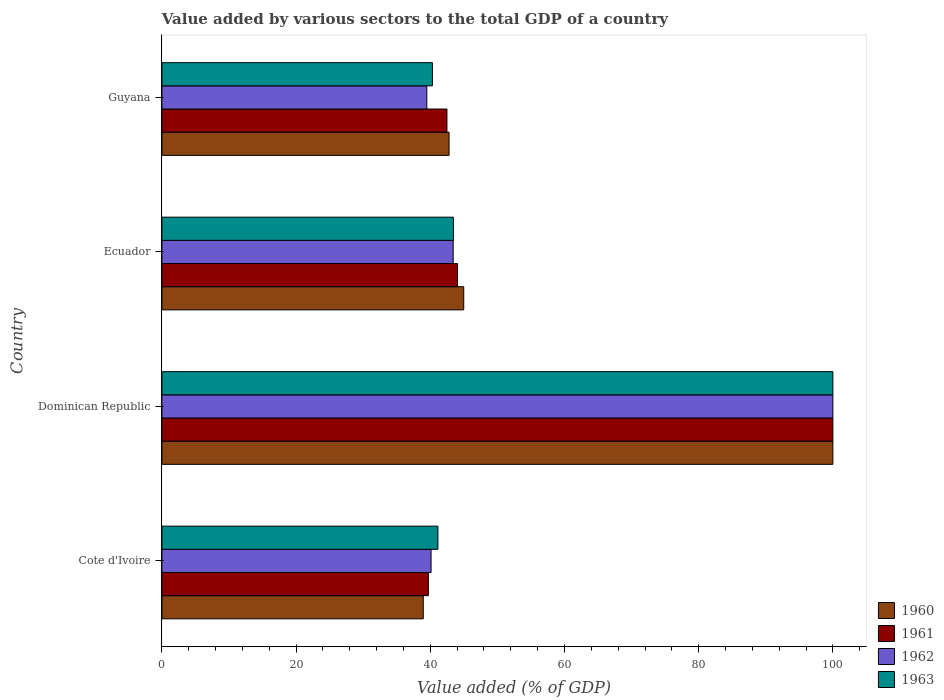How many different coloured bars are there?
Give a very brief answer. 4. Are the number of bars per tick equal to the number of legend labels?
Provide a short and direct response. Yes. Are the number of bars on each tick of the Y-axis equal?
Provide a succinct answer. Yes. What is the label of the 4th group of bars from the top?
Your answer should be very brief. Cote d'Ivoire. What is the value added by various sectors to the total GDP in 1961 in Cote d'Ivoire?
Your answer should be compact. 39.71. Across all countries, what is the maximum value added by various sectors to the total GDP in 1960?
Your response must be concise. 100. Across all countries, what is the minimum value added by various sectors to the total GDP in 1962?
Ensure brevity in your answer.  39.48. In which country was the value added by various sectors to the total GDP in 1963 maximum?
Ensure brevity in your answer.  Dominican Republic. In which country was the value added by various sectors to the total GDP in 1960 minimum?
Make the answer very short. Cote d'Ivoire. What is the total value added by various sectors to the total GDP in 1960 in the graph?
Make the answer very short. 226.74. What is the difference between the value added by various sectors to the total GDP in 1963 in Dominican Republic and that in Ecuador?
Offer a very short reply. 56.56. What is the difference between the value added by various sectors to the total GDP in 1963 in Guyana and the value added by various sectors to the total GDP in 1960 in Cote d'Ivoire?
Make the answer very short. 1.36. What is the average value added by various sectors to the total GDP in 1963 per country?
Keep it short and to the point. 56.22. What is the ratio of the value added by various sectors to the total GDP in 1963 in Cote d'Ivoire to that in Ecuador?
Ensure brevity in your answer.  0.95. Is the difference between the value added by various sectors to the total GDP in 1960 in Cote d'Ivoire and Dominican Republic greater than the difference between the value added by various sectors to the total GDP in 1963 in Cote d'Ivoire and Dominican Republic?
Provide a succinct answer. No. What is the difference between the highest and the second highest value added by various sectors to the total GDP in 1962?
Ensure brevity in your answer.  56.59. What is the difference between the highest and the lowest value added by various sectors to the total GDP in 1962?
Give a very brief answer. 60.52. Is the sum of the value added by various sectors to the total GDP in 1962 in Cote d'Ivoire and Ecuador greater than the maximum value added by various sectors to the total GDP in 1961 across all countries?
Keep it short and to the point. No. What does the 3rd bar from the top in Guyana represents?
Keep it short and to the point. 1961. Are all the bars in the graph horizontal?
Offer a terse response. Yes. How many countries are there in the graph?
Make the answer very short. 4. Does the graph contain any zero values?
Give a very brief answer. No. How many legend labels are there?
Your answer should be very brief. 4. How are the legend labels stacked?
Provide a short and direct response. Vertical. What is the title of the graph?
Your answer should be very brief. Value added by various sectors to the total GDP of a country. What is the label or title of the X-axis?
Keep it short and to the point. Value added (% of GDP). What is the Value added (% of GDP) of 1960 in Cote d'Ivoire?
Offer a terse response. 38.95. What is the Value added (% of GDP) in 1961 in Cote d'Ivoire?
Your response must be concise. 39.71. What is the Value added (% of GDP) of 1962 in Cote d'Ivoire?
Your answer should be compact. 40.11. What is the Value added (% of GDP) of 1963 in Cote d'Ivoire?
Make the answer very short. 41.13. What is the Value added (% of GDP) of 1960 in Dominican Republic?
Offer a very short reply. 100. What is the Value added (% of GDP) in 1961 in Dominican Republic?
Make the answer very short. 100. What is the Value added (% of GDP) in 1963 in Dominican Republic?
Provide a short and direct response. 100. What is the Value added (% of GDP) of 1960 in Ecuador?
Keep it short and to the point. 44.99. What is the Value added (% of GDP) of 1961 in Ecuador?
Make the answer very short. 44.05. What is the Value added (% of GDP) in 1962 in Ecuador?
Your answer should be compact. 43.41. What is the Value added (% of GDP) in 1963 in Ecuador?
Offer a very short reply. 43.44. What is the Value added (% of GDP) of 1960 in Guyana?
Ensure brevity in your answer.  42.8. What is the Value added (% of GDP) of 1961 in Guyana?
Make the answer very short. 42.48. What is the Value added (% of GDP) of 1962 in Guyana?
Offer a very short reply. 39.48. What is the Value added (% of GDP) of 1963 in Guyana?
Offer a very short reply. 40.31. Across all countries, what is the maximum Value added (% of GDP) of 1962?
Offer a terse response. 100. Across all countries, what is the minimum Value added (% of GDP) in 1960?
Your answer should be very brief. 38.95. Across all countries, what is the minimum Value added (% of GDP) of 1961?
Provide a short and direct response. 39.71. Across all countries, what is the minimum Value added (% of GDP) in 1962?
Your answer should be compact. 39.48. Across all countries, what is the minimum Value added (% of GDP) in 1963?
Make the answer very short. 40.31. What is the total Value added (% of GDP) of 1960 in the graph?
Keep it short and to the point. 226.74. What is the total Value added (% of GDP) of 1961 in the graph?
Keep it short and to the point. 226.25. What is the total Value added (% of GDP) of 1962 in the graph?
Provide a short and direct response. 223.01. What is the total Value added (% of GDP) of 1963 in the graph?
Offer a terse response. 224.89. What is the difference between the Value added (% of GDP) in 1960 in Cote d'Ivoire and that in Dominican Republic?
Make the answer very short. -61.05. What is the difference between the Value added (% of GDP) in 1961 in Cote d'Ivoire and that in Dominican Republic?
Give a very brief answer. -60.29. What is the difference between the Value added (% of GDP) in 1962 in Cote d'Ivoire and that in Dominican Republic?
Give a very brief answer. -59.89. What is the difference between the Value added (% of GDP) of 1963 in Cote d'Ivoire and that in Dominican Republic?
Offer a very short reply. -58.87. What is the difference between the Value added (% of GDP) in 1960 in Cote d'Ivoire and that in Ecuador?
Provide a succinct answer. -6.03. What is the difference between the Value added (% of GDP) of 1961 in Cote d'Ivoire and that in Ecuador?
Give a very brief answer. -4.34. What is the difference between the Value added (% of GDP) in 1962 in Cote d'Ivoire and that in Ecuador?
Give a very brief answer. -3.3. What is the difference between the Value added (% of GDP) of 1963 in Cote d'Ivoire and that in Ecuador?
Make the answer very short. -2.31. What is the difference between the Value added (% of GDP) of 1960 in Cote d'Ivoire and that in Guyana?
Offer a terse response. -3.84. What is the difference between the Value added (% of GDP) in 1961 in Cote d'Ivoire and that in Guyana?
Make the answer very short. -2.77. What is the difference between the Value added (% of GDP) in 1962 in Cote d'Ivoire and that in Guyana?
Your response must be concise. 0.63. What is the difference between the Value added (% of GDP) in 1963 in Cote d'Ivoire and that in Guyana?
Make the answer very short. 0.82. What is the difference between the Value added (% of GDP) in 1960 in Dominican Republic and that in Ecuador?
Give a very brief answer. 55.02. What is the difference between the Value added (% of GDP) in 1961 in Dominican Republic and that in Ecuador?
Provide a short and direct response. 55.95. What is the difference between the Value added (% of GDP) in 1962 in Dominican Republic and that in Ecuador?
Your answer should be very brief. 56.59. What is the difference between the Value added (% of GDP) of 1963 in Dominican Republic and that in Ecuador?
Offer a terse response. 56.56. What is the difference between the Value added (% of GDP) of 1960 in Dominican Republic and that in Guyana?
Your response must be concise. 57.2. What is the difference between the Value added (% of GDP) of 1961 in Dominican Republic and that in Guyana?
Offer a terse response. 57.52. What is the difference between the Value added (% of GDP) in 1962 in Dominican Republic and that in Guyana?
Offer a very short reply. 60.52. What is the difference between the Value added (% of GDP) of 1963 in Dominican Republic and that in Guyana?
Your response must be concise. 59.69. What is the difference between the Value added (% of GDP) in 1960 in Ecuador and that in Guyana?
Your answer should be very brief. 2.19. What is the difference between the Value added (% of GDP) of 1961 in Ecuador and that in Guyana?
Ensure brevity in your answer.  1.57. What is the difference between the Value added (% of GDP) in 1962 in Ecuador and that in Guyana?
Offer a very short reply. 3.93. What is the difference between the Value added (% of GDP) of 1963 in Ecuador and that in Guyana?
Your answer should be compact. 3.13. What is the difference between the Value added (% of GDP) in 1960 in Cote d'Ivoire and the Value added (% of GDP) in 1961 in Dominican Republic?
Your answer should be compact. -61.05. What is the difference between the Value added (% of GDP) of 1960 in Cote d'Ivoire and the Value added (% of GDP) of 1962 in Dominican Republic?
Your response must be concise. -61.05. What is the difference between the Value added (% of GDP) in 1960 in Cote d'Ivoire and the Value added (% of GDP) in 1963 in Dominican Republic?
Give a very brief answer. -61.05. What is the difference between the Value added (% of GDP) in 1961 in Cote d'Ivoire and the Value added (% of GDP) in 1962 in Dominican Republic?
Make the answer very short. -60.29. What is the difference between the Value added (% of GDP) of 1961 in Cote d'Ivoire and the Value added (% of GDP) of 1963 in Dominican Republic?
Make the answer very short. -60.29. What is the difference between the Value added (% of GDP) of 1962 in Cote d'Ivoire and the Value added (% of GDP) of 1963 in Dominican Republic?
Make the answer very short. -59.89. What is the difference between the Value added (% of GDP) of 1960 in Cote d'Ivoire and the Value added (% of GDP) of 1961 in Ecuador?
Make the answer very short. -5.1. What is the difference between the Value added (% of GDP) of 1960 in Cote d'Ivoire and the Value added (% of GDP) of 1962 in Ecuador?
Ensure brevity in your answer.  -4.46. What is the difference between the Value added (% of GDP) in 1960 in Cote d'Ivoire and the Value added (% of GDP) in 1963 in Ecuador?
Give a very brief answer. -4.49. What is the difference between the Value added (% of GDP) of 1961 in Cote d'Ivoire and the Value added (% of GDP) of 1962 in Ecuador?
Provide a short and direct response. -3.7. What is the difference between the Value added (% of GDP) in 1961 in Cote d'Ivoire and the Value added (% of GDP) in 1963 in Ecuador?
Ensure brevity in your answer.  -3.73. What is the difference between the Value added (% of GDP) of 1962 in Cote d'Ivoire and the Value added (% of GDP) of 1963 in Ecuador?
Keep it short and to the point. -3.33. What is the difference between the Value added (% of GDP) in 1960 in Cote d'Ivoire and the Value added (% of GDP) in 1961 in Guyana?
Your answer should be very brief. -3.53. What is the difference between the Value added (% of GDP) of 1960 in Cote d'Ivoire and the Value added (% of GDP) of 1962 in Guyana?
Your response must be concise. -0.53. What is the difference between the Value added (% of GDP) of 1960 in Cote d'Ivoire and the Value added (% of GDP) of 1963 in Guyana?
Offer a terse response. -1.36. What is the difference between the Value added (% of GDP) of 1961 in Cote d'Ivoire and the Value added (% of GDP) of 1962 in Guyana?
Your answer should be very brief. 0.23. What is the difference between the Value added (% of GDP) in 1961 in Cote d'Ivoire and the Value added (% of GDP) in 1963 in Guyana?
Your response must be concise. -0.6. What is the difference between the Value added (% of GDP) in 1962 in Cote d'Ivoire and the Value added (% of GDP) in 1963 in Guyana?
Provide a short and direct response. -0.2. What is the difference between the Value added (% of GDP) in 1960 in Dominican Republic and the Value added (% of GDP) in 1961 in Ecuador?
Ensure brevity in your answer.  55.95. What is the difference between the Value added (% of GDP) of 1960 in Dominican Republic and the Value added (% of GDP) of 1962 in Ecuador?
Provide a succinct answer. 56.59. What is the difference between the Value added (% of GDP) of 1960 in Dominican Republic and the Value added (% of GDP) of 1963 in Ecuador?
Your answer should be very brief. 56.56. What is the difference between the Value added (% of GDP) of 1961 in Dominican Republic and the Value added (% of GDP) of 1962 in Ecuador?
Provide a succinct answer. 56.59. What is the difference between the Value added (% of GDP) in 1961 in Dominican Republic and the Value added (% of GDP) in 1963 in Ecuador?
Offer a very short reply. 56.56. What is the difference between the Value added (% of GDP) of 1962 in Dominican Republic and the Value added (% of GDP) of 1963 in Ecuador?
Make the answer very short. 56.56. What is the difference between the Value added (% of GDP) in 1960 in Dominican Republic and the Value added (% of GDP) in 1961 in Guyana?
Give a very brief answer. 57.52. What is the difference between the Value added (% of GDP) in 1960 in Dominican Republic and the Value added (% of GDP) in 1962 in Guyana?
Keep it short and to the point. 60.52. What is the difference between the Value added (% of GDP) in 1960 in Dominican Republic and the Value added (% of GDP) in 1963 in Guyana?
Your answer should be very brief. 59.69. What is the difference between the Value added (% of GDP) in 1961 in Dominican Republic and the Value added (% of GDP) in 1962 in Guyana?
Ensure brevity in your answer.  60.52. What is the difference between the Value added (% of GDP) in 1961 in Dominican Republic and the Value added (% of GDP) in 1963 in Guyana?
Give a very brief answer. 59.69. What is the difference between the Value added (% of GDP) in 1962 in Dominican Republic and the Value added (% of GDP) in 1963 in Guyana?
Your answer should be compact. 59.69. What is the difference between the Value added (% of GDP) in 1960 in Ecuador and the Value added (% of GDP) in 1961 in Guyana?
Make the answer very short. 2.5. What is the difference between the Value added (% of GDP) of 1960 in Ecuador and the Value added (% of GDP) of 1962 in Guyana?
Your response must be concise. 5.5. What is the difference between the Value added (% of GDP) in 1960 in Ecuador and the Value added (% of GDP) in 1963 in Guyana?
Give a very brief answer. 4.67. What is the difference between the Value added (% of GDP) of 1961 in Ecuador and the Value added (% of GDP) of 1962 in Guyana?
Ensure brevity in your answer.  4.57. What is the difference between the Value added (% of GDP) of 1961 in Ecuador and the Value added (% of GDP) of 1963 in Guyana?
Keep it short and to the point. 3.74. What is the difference between the Value added (% of GDP) in 1962 in Ecuador and the Value added (% of GDP) in 1963 in Guyana?
Your answer should be very brief. 3.1. What is the average Value added (% of GDP) of 1960 per country?
Your answer should be compact. 56.68. What is the average Value added (% of GDP) in 1961 per country?
Offer a terse response. 56.56. What is the average Value added (% of GDP) of 1962 per country?
Provide a short and direct response. 55.75. What is the average Value added (% of GDP) of 1963 per country?
Provide a succinct answer. 56.22. What is the difference between the Value added (% of GDP) of 1960 and Value added (% of GDP) of 1961 in Cote d'Ivoire?
Provide a succinct answer. -0.76. What is the difference between the Value added (% of GDP) in 1960 and Value added (% of GDP) in 1962 in Cote d'Ivoire?
Your answer should be compact. -1.16. What is the difference between the Value added (% of GDP) of 1960 and Value added (% of GDP) of 1963 in Cote d'Ivoire?
Offer a very short reply. -2.18. What is the difference between the Value added (% of GDP) in 1961 and Value added (% of GDP) in 1962 in Cote d'Ivoire?
Offer a very short reply. -0.4. What is the difference between the Value added (% of GDP) of 1961 and Value added (% of GDP) of 1963 in Cote d'Ivoire?
Make the answer very short. -1.42. What is the difference between the Value added (% of GDP) in 1962 and Value added (% of GDP) in 1963 in Cote d'Ivoire?
Give a very brief answer. -1.02. What is the difference between the Value added (% of GDP) in 1960 and Value added (% of GDP) in 1963 in Dominican Republic?
Make the answer very short. 0. What is the difference between the Value added (% of GDP) in 1961 and Value added (% of GDP) in 1963 in Dominican Republic?
Keep it short and to the point. 0. What is the difference between the Value added (% of GDP) of 1962 and Value added (% of GDP) of 1963 in Dominican Republic?
Your answer should be compact. 0. What is the difference between the Value added (% of GDP) of 1960 and Value added (% of GDP) of 1961 in Ecuador?
Ensure brevity in your answer.  0.93. What is the difference between the Value added (% of GDP) in 1960 and Value added (% of GDP) in 1962 in Ecuador?
Give a very brief answer. 1.57. What is the difference between the Value added (% of GDP) in 1960 and Value added (% of GDP) in 1963 in Ecuador?
Your response must be concise. 1.54. What is the difference between the Value added (% of GDP) of 1961 and Value added (% of GDP) of 1962 in Ecuador?
Your response must be concise. 0.64. What is the difference between the Value added (% of GDP) in 1961 and Value added (% of GDP) in 1963 in Ecuador?
Your answer should be very brief. 0.61. What is the difference between the Value added (% of GDP) of 1962 and Value added (% of GDP) of 1963 in Ecuador?
Your answer should be compact. -0.03. What is the difference between the Value added (% of GDP) of 1960 and Value added (% of GDP) of 1961 in Guyana?
Keep it short and to the point. 0.32. What is the difference between the Value added (% of GDP) in 1960 and Value added (% of GDP) in 1962 in Guyana?
Offer a very short reply. 3.31. What is the difference between the Value added (% of GDP) of 1960 and Value added (% of GDP) of 1963 in Guyana?
Provide a succinct answer. 2.48. What is the difference between the Value added (% of GDP) of 1961 and Value added (% of GDP) of 1962 in Guyana?
Your response must be concise. 3. What is the difference between the Value added (% of GDP) in 1961 and Value added (% of GDP) in 1963 in Guyana?
Make the answer very short. 2.17. What is the difference between the Value added (% of GDP) in 1962 and Value added (% of GDP) in 1963 in Guyana?
Give a very brief answer. -0.83. What is the ratio of the Value added (% of GDP) in 1960 in Cote d'Ivoire to that in Dominican Republic?
Your response must be concise. 0.39. What is the ratio of the Value added (% of GDP) in 1961 in Cote d'Ivoire to that in Dominican Republic?
Your answer should be very brief. 0.4. What is the ratio of the Value added (% of GDP) in 1962 in Cote d'Ivoire to that in Dominican Republic?
Give a very brief answer. 0.4. What is the ratio of the Value added (% of GDP) in 1963 in Cote d'Ivoire to that in Dominican Republic?
Offer a terse response. 0.41. What is the ratio of the Value added (% of GDP) in 1960 in Cote d'Ivoire to that in Ecuador?
Make the answer very short. 0.87. What is the ratio of the Value added (% of GDP) of 1961 in Cote d'Ivoire to that in Ecuador?
Give a very brief answer. 0.9. What is the ratio of the Value added (% of GDP) in 1962 in Cote d'Ivoire to that in Ecuador?
Offer a very short reply. 0.92. What is the ratio of the Value added (% of GDP) of 1963 in Cote d'Ivoire to that in Ecuador?
Make the answer very short. 0.95. What is the ratio of the Value added (% of GDP) of 1960 in Cote d'Ivoire to that in Guyana?
Provide a succinct answer. 0.91. What is the ratio of the Value added (% of GDP) of 1961 in Cote d'Ivoire to that in Guyana?
Offer a terse response. 0.93. What is the ratio of the Value added (% of GDP) in 1963 in Cote d'Ivoire to that in Guyana?
Provide a short and direct response. 1.02. What is the ratio of the Value added (% of GDP) in 1960 in Dominican Republic to that in Ecuador?
Your response must be concise. 2.22. What is the ratio of the Value added (% of GDP) of 1961 in Dominican Republic to that in Ecuador?
Provide a succinct answer. 2.27. What is the ratio of the Value added (% of GDP) of 1962 in Dominican Republic to that in Ecuador?
Your answer should be very brief. 2.3. What is the ratio of the Value added (% of GDP) of 1963 in Dominican Republic to that in Ecuador?
Your answer should be compact. 2.3. What is the ratio of the Value added (% of GDP) of 1960 in Dominican Republic to that in Guyana?
Keep it short and to the point. 2.34. What is the ratio of the Value added (% of GDP) in 1961 in Dominican Republic to that in Guyana?
Your response must be concise. 2.35. What is the ratio of the Value added (% of GDP) in 1962 in Dominican Republic to that in Guyana?
Keep it short and to the point. 2.53. What is the ratio of the Value added (% of GDP) of 1963 in Dominican Republic to that in Guyana?
Offer a terse response. 2.48. What is the ratio of the Value added (% of GDP) of 1960 in Ecuador to that in Guyana?
Make the answer very short. 1.05. What is the ratio of the Value added (% of GDP) in 1962 in Ecuador to that in Guyana?
Provide a succinct answer. 1.1. What is the ratio of the Value added (% of GDP) in 1963 in Ecuador to that in Guyana?
Your response must be concise. 1.08. What is the difference between the highest and the second highest Value added (% of GDP) of 1960?
Ensure brevity in your answer.  55.02. What is the difference between the highest and the second highest Value added (% of GDP) in 1961?
Provide a succinct answer. 55.95. What is the difference between the highest and the second highest Value added (% of GDP) of 1962?
Provide a short and direct response. 56.59. What is the difference between the highest and the second highest Value added (% of GDP) in 1963?
Offer a very short reply. 56.56. What is the difference between the highest and the lowest Value added (% of GDP) in 1960?
Keep it short and to the point. 61.05. What is the difference between the highest and the lowest Value added (% of GDP) in 1961?
Your answer should be very brief. 60.29. What is the difference between the highest and the lowest Value added (% of GDP) of 1962?
Your response must be concise. 60.52. What is the difference between the highest and the lowest Value added (% of GDP) of 1963?
Your answer should be very brief. 59.69. 